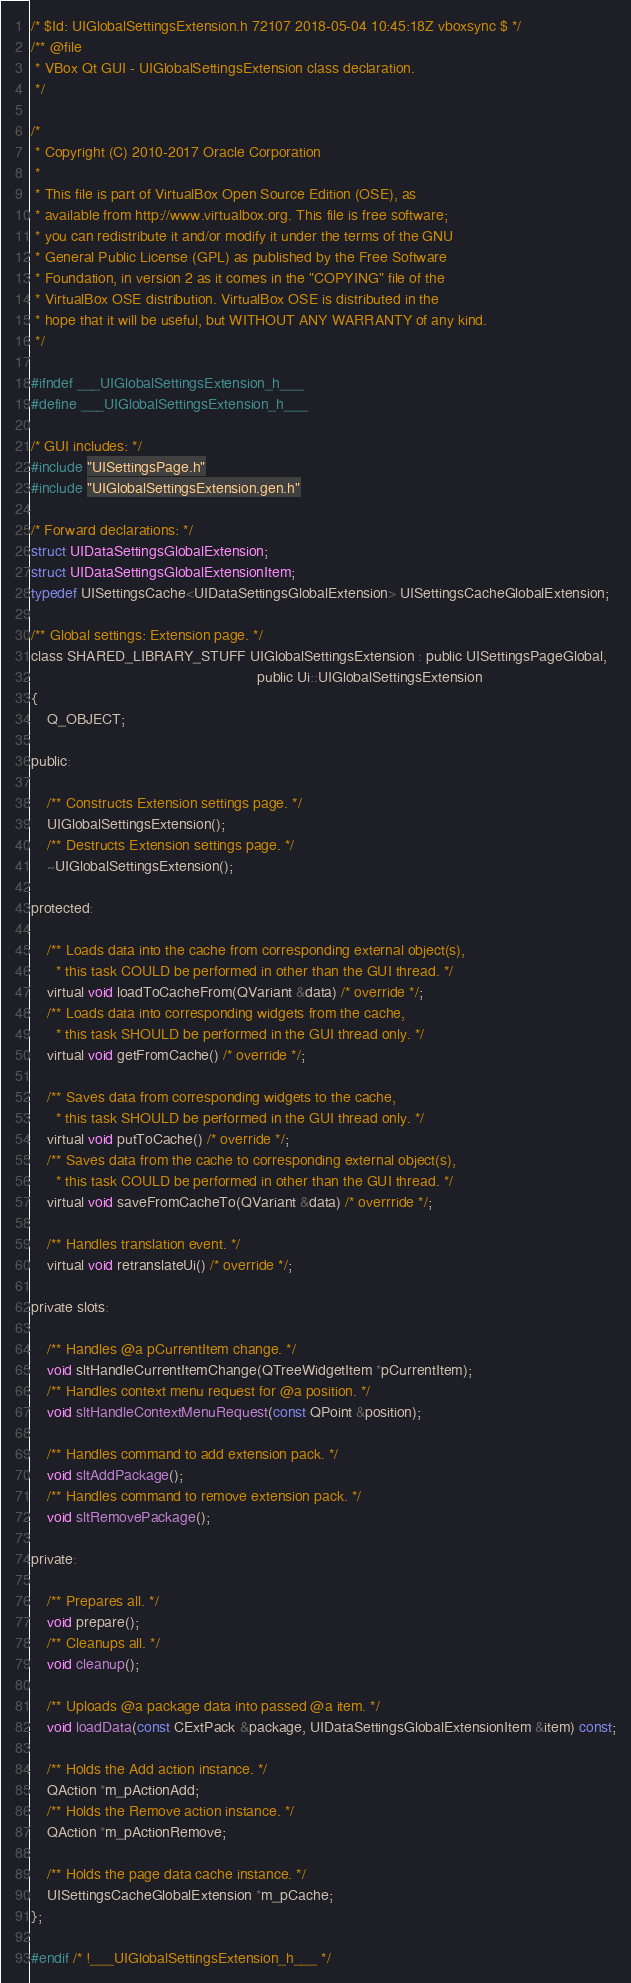<code> <loc_0><loc_0><loc_500><loc_500><_C_>/* $Id: UIGlobalSettingsExtension.h 72107 2018-05-04 10:45:18Z vboxsync $ */
/** @file
 * VBox Qt GUI - UIGlobalSettingsExtension class declaration.
 */

/*
 * Copyright (C) 2010-2017 Oracle Corporation
 *
 * This file is part of VirtualBox Open Source Edition (OSE), as
 * available from http://www.virtualbox.org. This file is free software;
 * you can redistribute it and/or modify it under the terms of the GNU
 * General Public License (GPL) as published by the Free Software
 * Foundation, in version 2 as it comes in the "COPYING" file of the
 * VirtualBox OSE distribution. VirtualBox OSE is distributed in the
 * hope that it will be useful, but WITHOUT ANY WARRANTY of any kind.
 */

#ifndef ___UIGlobalSettingsExtension_h___
#define ___UIGlobalSettingsExtension_h___

/* GUI includes: */
#include "UISettingsPage.h"
#include "UIGlobalSettingsExtension.gen.h"

/* Forward declarations: */
struct UIDataSettingsGlobalExtension;
struct UIDataSettingsGlobalExtensionItem;
typedef UISettingsCache<UIDataSettingsGlobalExtension> UISettingsCacheGlobalExtension;

/** Global settings: Extension page. */
class SHARED_LIBRARY_STUFF UIGlobalSettingsExtension : public UISettingsPageGlobal,
                                                       public Ui::UIGlobalSettingsExtension
{
    Q_OBJECT;

public:

    /** Constructs Extension settings page. */
    UIGlobalSettingsExtension();
    /** Destructs Extension settings page. */
    ~UIGlobalSettingsExtension();

protected:

    /** Loads data into the cache from corresponding external object(s),
      * this task COULD be performed in other than the GUI thread. */
    virtual void loadToCacheFrom(QVariant &data) /* override */;
    /** Loads data into corresponding widgets from the cache,
      * this task SHOULD be performed in the GUI thread only. */
    virtual void getFromCache() /* override */;

    /** Saves data from corresponding widgets to the cache,
      * this task SHOULD be performed in the GUI thread only. */
    virtual void putToCache() /* override */;
    /** Saves data from the cache to corresponding external object(s),
      * this task COULD be performed in other than the GUI thread. */
    virtual void saveFromCacheTo(QVariant &data) /* overrride */;

    /** Handles translation event. */
    virtual void retranslateUi() /* override */;

private slots:

    /** Handles @a pCurrentItem change. */
    void sltHandleCurrentItemChange(QTreeWidgetItem *pCurrentItem);
    /** Handles context menu request for @a position. */
    void sltHandleContextMenuRequest(const QPoint &position);

    /** Handles command to add extension pack. */
    void sltAddPackage();
    /** Handles command to remove extension pack. */
    void sltRemovePackage();

private:

    /** Prepares all. */
    void prepare();
    /** Cleanups all. */
    void cleanup();

    /** Uploads @a package data into passed @a item. */
    void loadData(const CExtPack &package, UIDataSettingsGlobalExtensionItem &item) const;

    /** Holds the Add action instance. */
    QAction *m_pActionAdd;
    /** Holds the Remove action instance. */
    QAction *m_pActionRemove;

    /** Holds the page data cache instance. */
    UISettingsCacheGlobalExtension *m_pCache;
};

#endif /* !___UIGlobalSettingsExtension_h___ */
</code> 